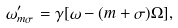<formula> <loc_0><loc_0><loc_500><loc_500>\omega ^ { \prime } _ { m \sigma } = \gamma [ \omega - ( m + \sigma ) \Omega ] ,</formula> 